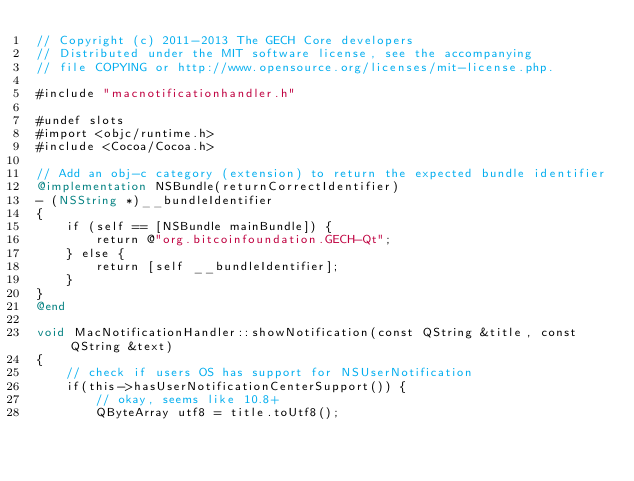<code> <loc_0><loc_0><loc_500><loc_500><_ObjectiveC_>// Copyright (c) 2011-2013 The GECH Core developers
// Distributed under the MIT software license, see the accompanying
// file COPYING or http://www.opensource.org/licenses/mit-license.php.

#include "macnotificationhandler.h"

#undef slots
#import <objc/runtime.h>
#include <Cocoa/Cocoa.h>

// Add an obj-c category (extension) to return the expected bundle identifier
@implementation NSBundle(returnCorrectIdentifier)
- (NSString *)__bundleIdentifier
{
    if (self == [NSBundle mainBundle]) {
        return @"org.bitcoinfoundation.GECH-Qt";
    } else {
        return [self __bundleIdentifier];
    }
}
@end

void MacNotificationHandler::showNotification(const QString &title, const QString &text)
{
    // check if users OS has support for NSUserNotification
    if(this->hasUserNotificationCenterSupport()) {
        // okay, seems like 10.8+
        QByteArray utf8 = title.toUtf8();</code> 